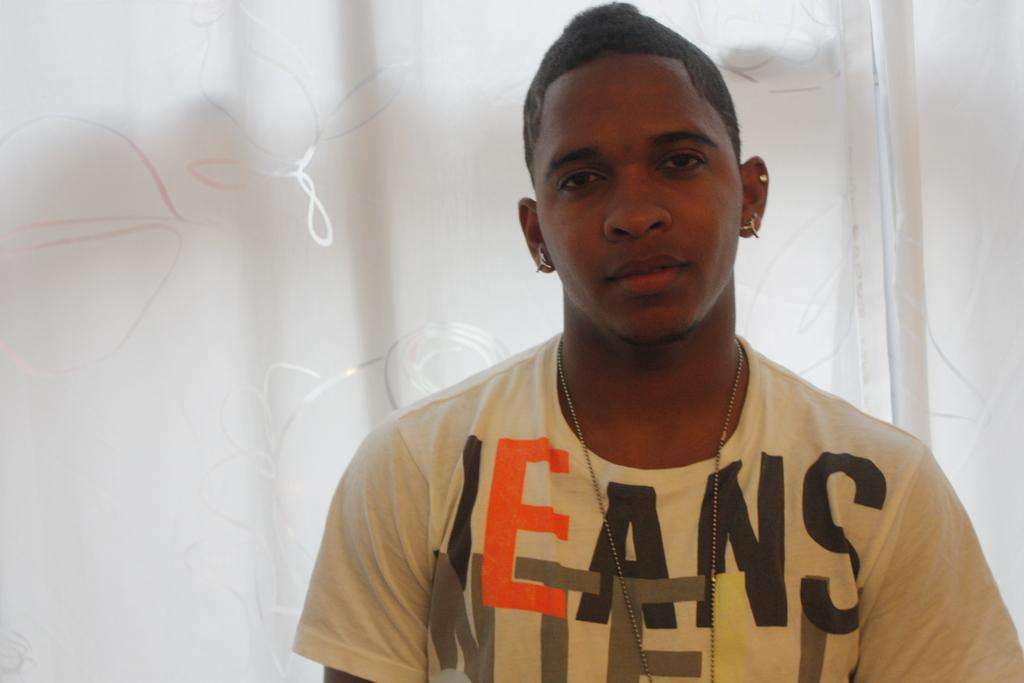Who is present in the image? There is a person in the image. What is the person wearing? The person is wearing a dress. What color is the background of the image? The background of the image is white. What is the person's opinion on division in the image? There is no indication of the person's opinion on division in the image, as it is focused on the person's appearance and the background color. 